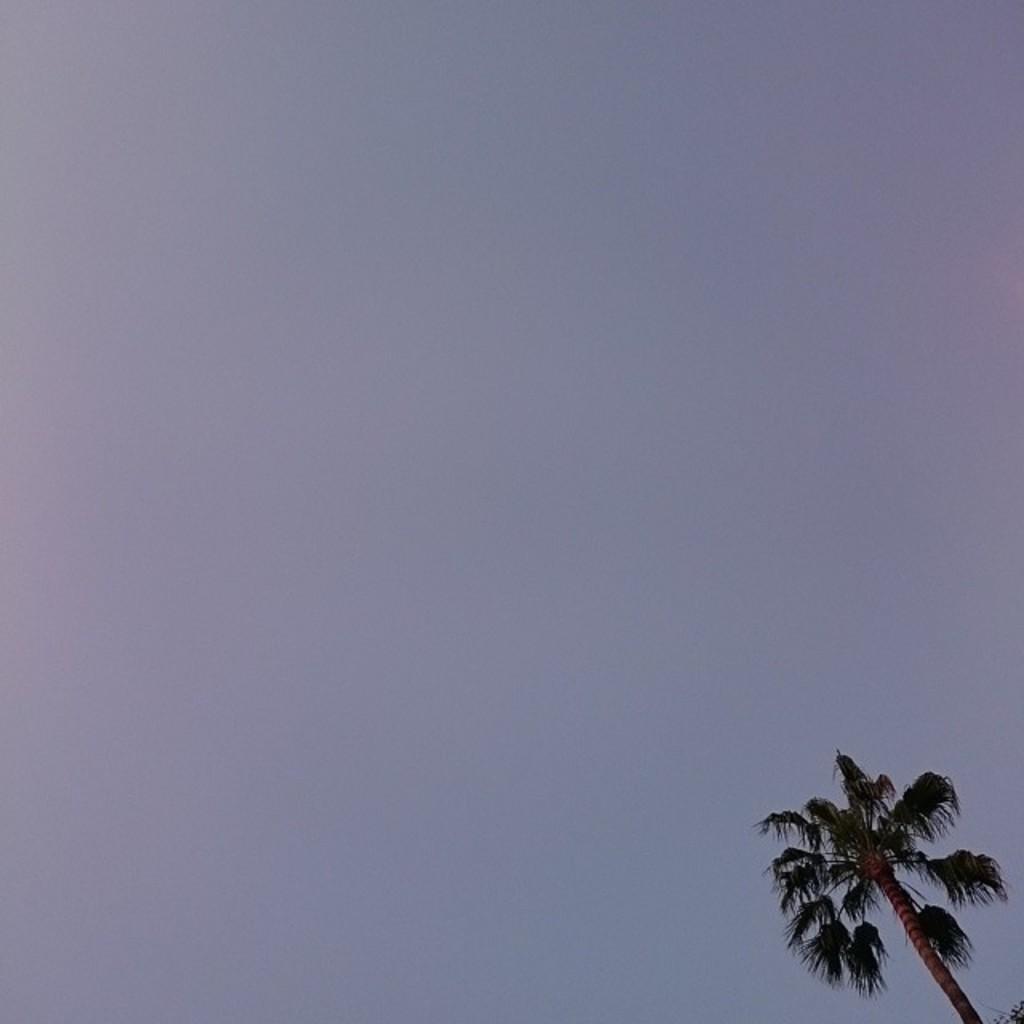Could you give a brief overview of what you see in this image? In this image we can see a tree and the sky on the background. 